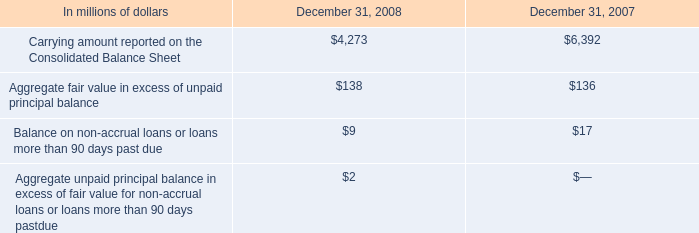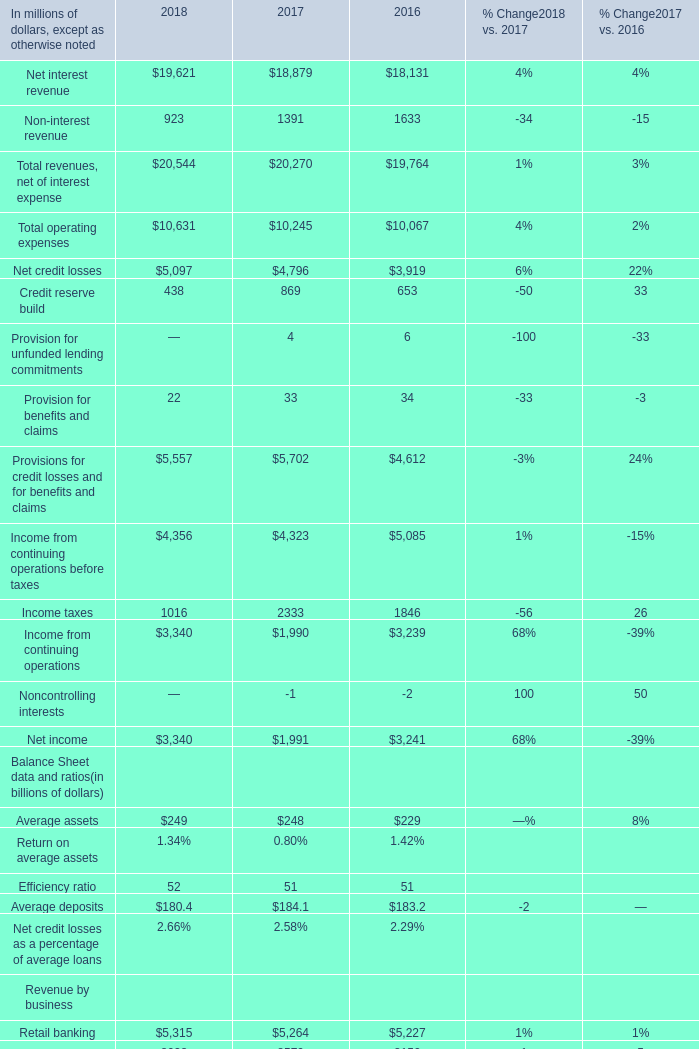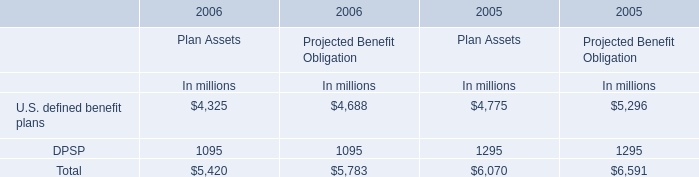What is the average amount of Income from continuing operations before taxes of 2017, and U.S. defined benefit plans of 2006 Plan Assets In millions ? 
Computations: ((4323.0 + 4325.0) / 2)
Answer: 4324.0. 